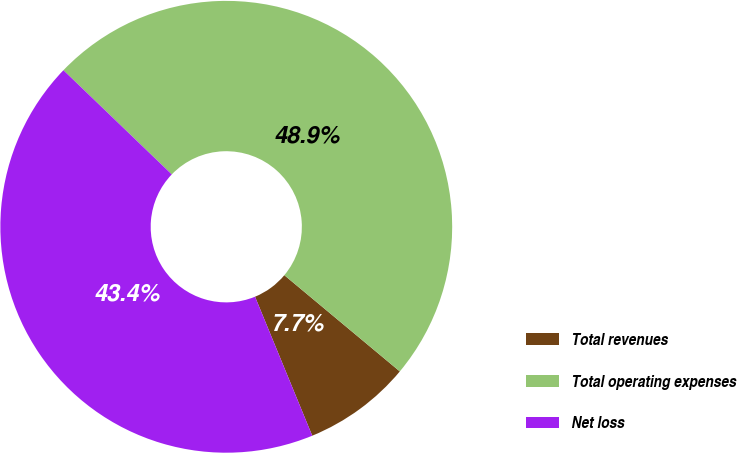<chart> <loc_0><loc_0><loc_500><loc_500><pie_chart><fcel>Total revenues<fcel>Total operating expenses<fcel>Net loss<nl><fcel>7.73%<fcel>48.87%<fcel>43.4%<nl></chart> 